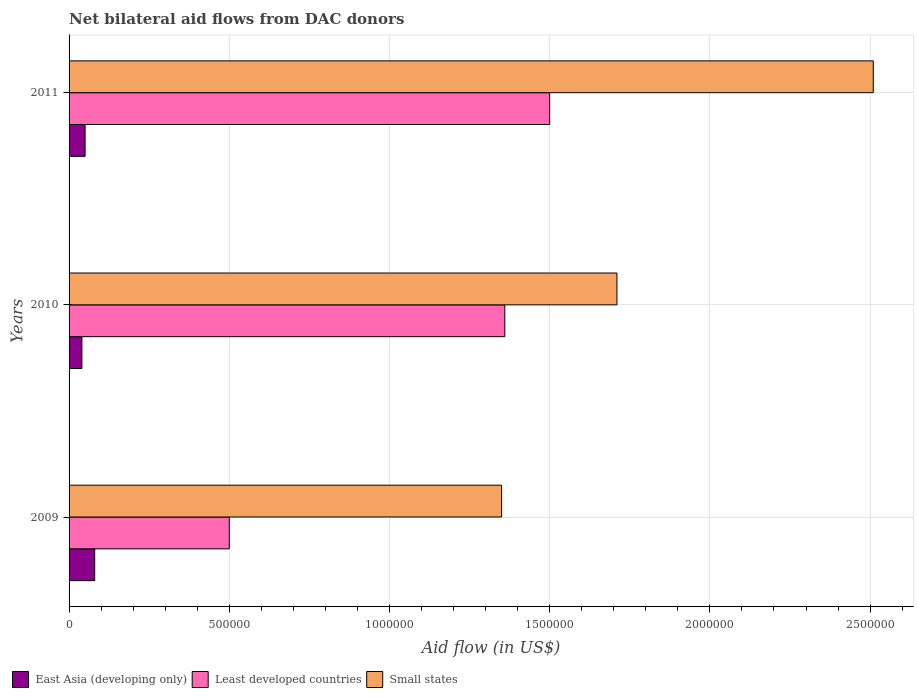How many different coloured bars are there?
Offer a terse response. 3. How many groups of bars are there?
Make the answer very short. 3. What is the label of the 3rd group of bars from the top?
Provide a succinct answer. 2009. In how many cases, is the number of bars for a given year not equal to the number of legend labels?
Your answer should be very brief. 0. What is the net bilateral aid flow in East Asia (developing only) in 2009?
Make the answer very short. 8.00e+04. Across all years, what is the maximum net bilateral aid flow in Small states?
Give a very brief answer. 2.51e+06. Across all years, what is the minimum net bilateral aid flow in East Asia (developing only)?
Offer a very short reply. 4.00e+04. What is the total net bilateral aid flow in Small states in the graph?
Your response must be concise. 5.57e+06. What is the difference between the net bilateral aid flow in Small states in 2009 and that in 2011?
Keep it short and to the point. -1.16e+06. What is the difference between the net bilateral aid flow in Small states in 2009 and the net bilateral aid flow in East Asia (developing only) in 2011?
Offer a very short reply. 1.30e+06. What is the average net bilateral aid flow in Small states per year?
Provide a short and direct response. 1.86e+06. In the year 2011, what is the difference between the net bilateral aid flow in Small states and net bilateral aid flow in East Asia (developing only)?
Offer a terse response. 2.46e+06. In how many years, is the net bilateral aid flow in East Asia (developing only) greater than 1300000 US$?
Make the answer very short. 0. What is the ratio of the net bilateral aid flow in Least developed countries in 2009 to that in 2011?
Offer a very short reply. 0.33. Is the difference between the net bilateral aid flow in Small states in 2009 and 2011 greater than the difference between the net bilateral aid flow in East Asia (developing only) in 2009 and 2011?
Offer a very short reply. No. What is the difference between the highest and the second highest net bilateral aid flow in East Asia (developing only)?
Keep it short and to the point. 3.00e+04. What is the difference between the highest and the lowest net bilateral aid flow in East Asia (developing only)?
Make the answer very short. 4.00e+04. What does the 1st bar from the top in 2011 represents?
Offer a very short reply. Small states. What does the 1st bar from the bottom in 2009 represents?
Provide a succinct answer. East Asia (developing only). Is it the case that in every year, the sum of the net bilateral aid flow in Small states and net bilateral aid flow in East Asia (developing only) is greater than the net bilateral aid flow in Least developed countries?
Your answer should be compact. Yes. How many bars are there?
Keep it short and to the point. 9. How many years are there in the graph?
Ensure brevity in your answer.  3. Are the values on the major ticks of X-axis written in scientific E-notation?
Offer a terse response. No. Does the graph contain any zero values?
Give a very brief answer. No. What is the title of the graph?
Keep it short and to the point. Net bilateral aid flows from DAC donors. What is the label or title of the X-axis?
Make the answer very short. Aid flow (in US$). What is the label or title of the Y-axis?
Your answer should be compact. Years. What is the Aid flow (in US$) in East Asia (developing only) in 2009?
Offer a very short reply. 8.00e+04. What is the Aid flow (in US$) of Least developed countries in 2009?
Keep it short and to the point. 5.00e+05. What is the Aid flow (in US$) of Small states in 2009?
Offer a terse response. 1.35e+06. What is the Aid flow (in US$) in East Asia (developing only) in 2010?
Make the answer very short. 4.00e+04. What is the Aid flow (in US$) in Least developed countries in 2010?
Your answer should be very brief. 1.36e+06. What is the Aid flow (in US$) of Small states in 2010?
Make the answer very short. 1.71e+06. What is the Aid flow (in US$) of Least developed countries in 2011?
Offer a very short reply. 1.50e+06. What is the Aid flow (in US$) in Small states in 2011?
Your answer should be compact. 2.51e+06. Across all years, what is the maximum Aid flow (in US$) in East Asia (developing only)?
Provide a succinct answer. 8.00e+04. Across all years, what is the maximum Aid flow (in US$) in Least developed countries?
Offer a very short reply. 1.50e+06. Across all years, what is the maximum Aid flow (in US$) in Small states?
Give a very brief answer. 2.51e+06. Across all years, what is the minimum Aid flow (in US$) in East Asia (developing only)?
Your answer should be compact. 4.00e+04. Across all years, what is the minimum Aid flow (in US$) in Least developed countries?
Your response must be concise. 5.00e+05. Across all years, what is the minimum Aid flow (in US$) of Small states?
Provide a short and direct response. 1.35e+06. What is the total Aid flow (in US$) of Least developed countries in the graph?
Offer a terse response. 3.36e+06. What is the total Aid flow (in US$) in Small states in the graph?
Give a very brief answer. 5.57e+06. What is the difference between the Aid flow (in US$) in Least developed countries in 2009 and that in 2010?
Provide a succinct answer. -8.60e+05. What is the difference between the Aid flow (in US$) in Small states in 2009 and that in 2010?
Offer a terse response. -3.60e+05. What is the difference between the Aid flow (in US$) of East Asia (developing only) in 2009 and that in 2011?
Ensure brevity in your answer.  3.00e+04. What is the difference between the Aid flow (in US$) of Small states in 2009 and that in 2011?
Give a very brief answer. -1.16e+06. What is the difference between the Aid flow (in US$) in East Asia (developing only) in 2010 and that in 2011?
Provide a succinct answer. -10000. What is the difference between the Aid flow (in US$) of Small states in 2010 and that in 2011?
Offer a very short reply. -8.00e+05. What is the difference between the Aid flow (in US$) in East Asia (developing only) in 2009 and the Aid flow (in US$) in Least developed countries in 2010?
Your answer should be very brief. -1.28e+06. What is the difference between the Aid flow (in US$) of East Asia (developing only) in 2009 and the Aid flow (in US$) of Small states in 2010?
Give a very brief answer. -1.63e+06. What is the difference between the Aid flow (in US$) of Least developed countries in 2009 and the Aid flow (in US$) of Small states in 2010?
Ensure brevity in your answer.  -1.21e+06. What is the difference between the Aid flow (in US$) in East Asia (developing only) in 2009 and the Aid flow (in US$) in Least developed countries in 2011?
Your answer should be very brief. -1.42e+06. What is the difference between the Aid flow (in US$) of East Asia (developing only) in 2009 and the Aid flow (in US$) of Small states in 2011?
Your response must be concise. -2.43e+06. What is the difference between the Aid flow (in US$) in Least developed countries in 2009 and the Aid flow (in US$) in Small states in 2011?
Your answer should be compact. -2.01e+06. What is the difference between the Aid flow (in US$) in East Asia (developing only) in 2010 and the Aid flow (in US$) in Least developed countries in 2011?
Offer a terse response. -1.46e+06. What is the difference between the Aid flow (in US$) in East Asia (developing only) in 2010 and the Aid flow (in US$) in Small states in 2011?
Make the answer very short. -2.47e+06. What is the difference between the Aid flow (in US$) in Least developed countries in 2010 and the Aid flow (in US$) in Small states in 2011?
Offer a terse response. -1.15e+06. What is the average Aid flow (in US$) of East Asia (developing only) per year?
Provide a succinct answer. 5.67e+04. What is the average Aid flow (in US$) in Least developed countries per year?
Offer a very short reply. 1.12e+06. What is the average Aid flow (in US$) in Small states per year?
Provide a succinct answer. 1.86e+06. In the year 2009, what is the difference between the Aid flow (in US$) in East Asia (developing only) and Aid flow (in US$) in Least developed countries?
Your response must be concise. -4.20e+05. In the year 2009, what is the difference between the Aid flow (in US$) in East Asia (developing only) and Aid flow (in US$) in Small states?
Your answer should be very brief. -1.27e+06. In the year 2009, what is the difference between the Aid flow (in US$) of Least developed countries and Aid flow (in US$) of Small states?
Give a very brief answer. -8.50e+05. In the year 2010, what is the difference between the Aid flow (in US$) of East Asia (developing only) and Aid flow (in US$) of Least developed countries?
Keep it short and to the point. -1.32e+06. In the year 2010, what is the difference between the Aid flow (in US$) in East Asia (developing only) and Aid flow (in US$) in Small states?
Your answer should be very brief. -1.67e+06. In the year 2010, what is the difference between the Aid flow (in US$) of Least developed countries and Aid flow (in US$) of Small states?
Ensure brevity in your answer.  -3.50e+05. In the year 2011, what is the difference between the Aid flow (in US$) of East Asia (developing only) and Aid flow (in US$) of Least developed countries?
Make the answer very short. -1.45e+06. In the year 2011, what is the difference between the Aid flow (in US$) in East Asia (developing only) and Aid flow (in US$) in Small states?
Offer a terse response. -2.46e+06. In the year 2011, what is the difference between the Aid flow (in US$) in Least developed countries and Aid flow (in US$) in Small states?
Your answer should be compact. -1.01e+06. What is the ratio of the Aid flow (in US$) of Least developed countries in 2009 to that in 2010?
Provide a succinct answer. 0.37. What is the ratio of the Aid flow (in US$) of Small states in 2009 to that in 2010?
Provide a succinct answer. 0.79. What is the ratio of the Aid flow (in US$) in Small states in 2009 to that in 2011?
Ensure brevity in your answer.  0.54. What is the ratio of the Aid flow (in US$) of East Asia (developing only) in 2010 to that in 2011?
Provide a short and direct response. 0.8. What is the ratio of the Aid flow (in US$) in Least developed countries in 2010 to that in 2011?
Give a very brief answer. 0.91. What is the ratio of the Aid flow (in US$) of Small states in 2010 to that in 2011?
Make the answer very short. 0.68. What is the difference between the highest and the second highest Aid flow (in US$) of Small states?
Offer a very short reply. 8.00e+05. What is the difference between the highest and the lowest Aid flow (in US$) in East Asia (developing only)?
Provide a succinct answer. 4.00e+04. What is the difference between the highest and the lowest Aid flow (in US$) in Small states?
Make the answer very short. 1.16e+06. 